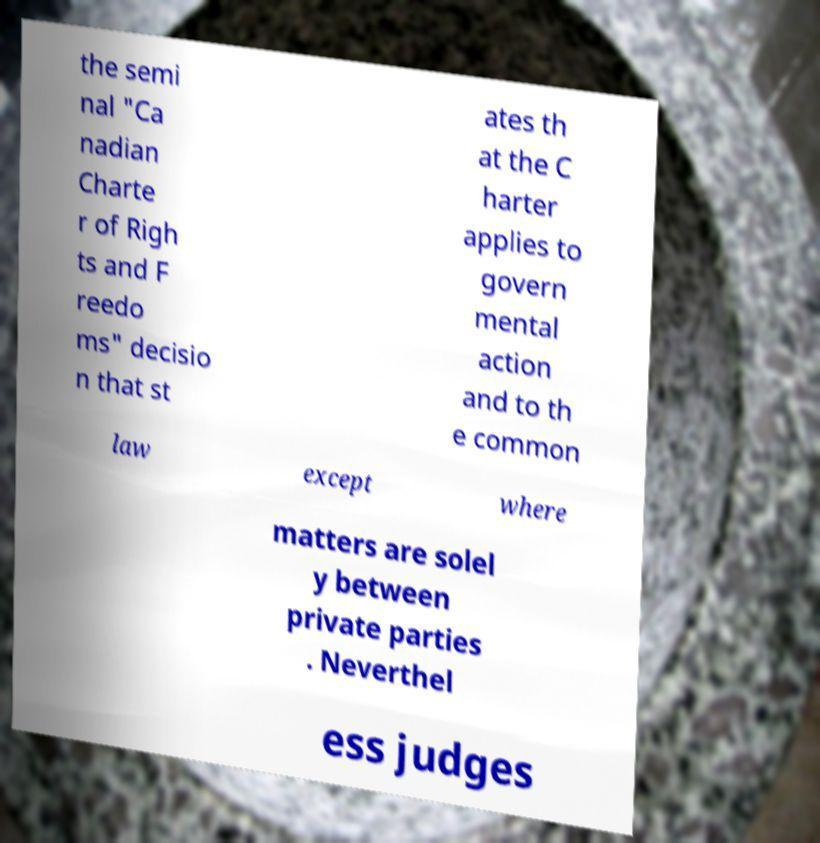Can you accurately transcribe the text from the provided image for me? the semi nal "Ca nadian Charte r of Righ ts and F reedo ms" decisio n that st ates th at the C harter applies to govern mental action and to th e common law except where matters are solel y between private parties . Neverthel ess judges 